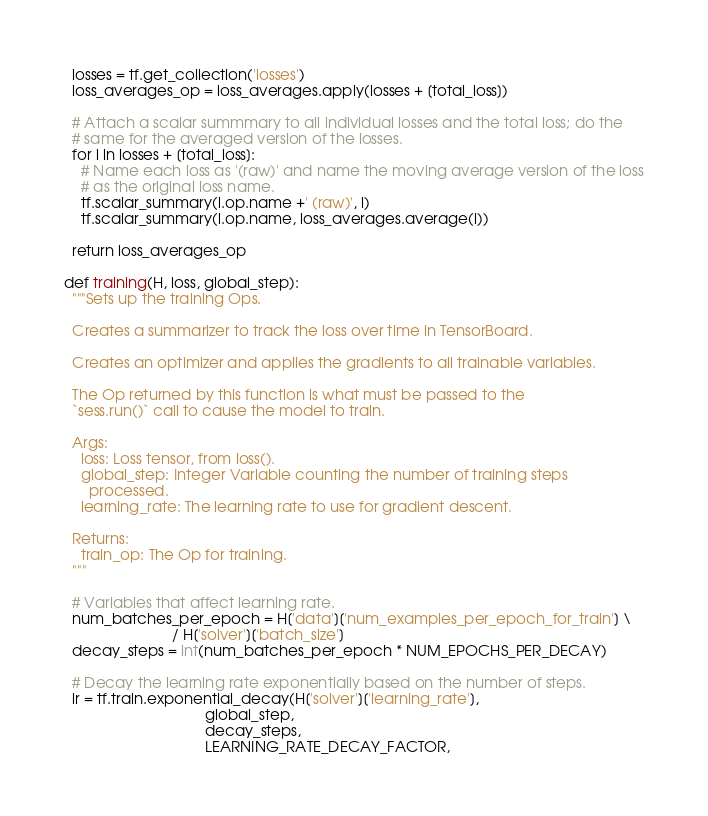Convert code to text. <code><loc_0><loc_0><loc_500><loc_500><_Python_>  losses = tf.get_collection('losses')
  loss_averages_op = loss_averages.apply(losses + [total_loss])

  # Attach a scalar summmary to all individual losses and the total loss; do the
  # same for the averaged version of the losses.
  for l in losses + [total_loss]:
    # Name each loss as '(raw)' and name the moving average version of the loss
    # as the original loss name.
    tf.scalar_summary(l.op.name +' (raw)', l)
    tf.scalar_summary(l.op.name, loss_averages.average(l))

  return loss_averages_op

def training(H, loss, global_step):
  """Sets up the training Ops.

  Creates a summarizer to track the loss over time in TensorBoard.

  Creates an optimizer and applies the gradients to all trainable variables.

  The Op returned by this function is what must be passed to the
  `sess.run()` call to cause the model to train.

  Args:
    loss: Loss tensor, from loss().
    global_step: Integer Variable counting the number of training steps
      processed.
    learning_rate: The learning rate to use for gradient descent.

  Returns:
    train_op: The Op for training.
  """

  # Variables that affect learning rate.
  num_batches_per_epoch = H['data']['num_examples_per_epoch_for_train'] \
                          / H['solver']['batch_size']
  decay_steps = int(num_batches_per_epoch * NUM_EPOCHS_PER_DECAY)

  # Decay the learning rate exponentially based on the number of steps.
  lr = tf.train.exponential_decay(H['solver']['learning_rate'],
                                  global_step,
                                  decay_steps,
                                  LEARNING_RATE_DECAY_FACTOR,</code> 